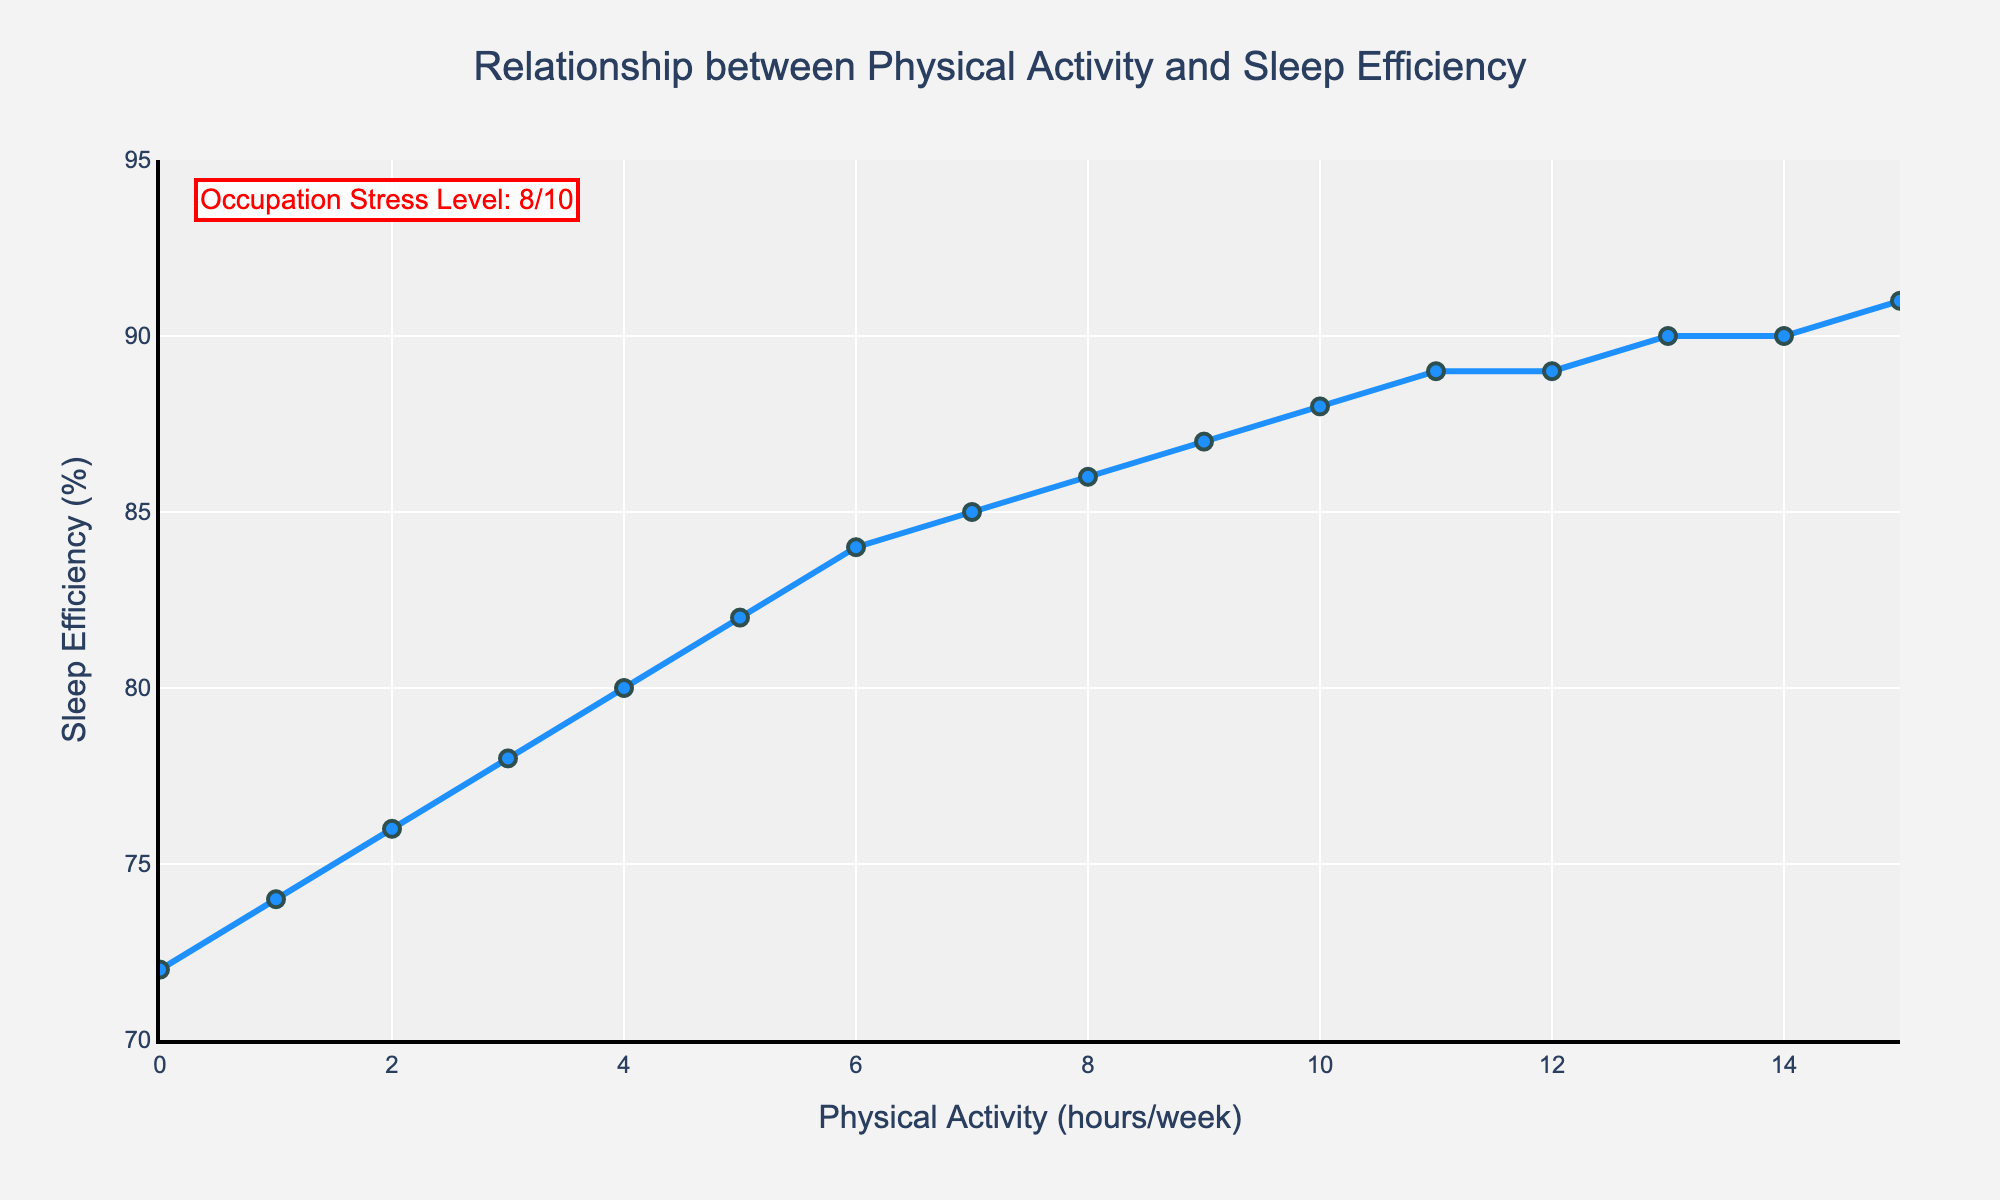What is the occupation stress level mentioned in the figure? The figure includes an annotation at the top left stating "Occupation Stress Level: 8/10".
Answer: 8/10 How does sleep efficiency change with increasing physical activity levels? The line chart shows a clear increasing trend of sleep efficiency as physical activity levels increase from 0 to 15 hours per week.
Answer: Increases What is the sleep efficiency at 10 hours of physical activity per week? From the chart, locate the point corresponding to 10 hours per week on the x-axis, then read the sleep efficiency on the y-axis, which is at 88%.
Answer: 88% At which physical activity level does sleep efficiency stop noticeably increasing? Sleep efficiency noticeably stops increasing at around 13 hours per week, with nearly equivalent values around 90%.
Answer: 13 hours per week Which physical activity level sees the highest sleep efficiency, and what is that efficiency? The highest sleep efficiency, which is 91%, occurs at the physical activity level of 15 hours per week.
Answer: 15 hours per week, 91% What is the average sleep efficiency between 0 and 5 hours of physical activity? Sum the sleep efficiencies at 0, 1, 2, 3, 4, and 5 hours per week (72 + 74 + 76 + 78 + 80 + 82) and then divide by the number of data points, which is 6. Average = (72 + 74 + 76 + 78 + 80 + 82) / 6 = 77%.
Answer: 77% Compare the sleep efficiency at 6 hours and 10 hours of physical activity per week. Which is higher and by how much? The sleep efficiency at 6 hours per week is 84%, and at 10 hours per week is 88%. The difference is 88% - 84% = 4%.
Answer: 10 hours per week, 4% What is the range of sleep efficiency values shown in the figure? The minimum sleep efficiency is 72% at 0 hours per week, and the maximum is 91% at 15 hours per week. The range is 91% - 72% = 19%.
Answer: 19% If an individual increases their physical activity from 5 to 8 hours per week, how much does their sleep efficiency improve? Sleep efficiency at 5 hours per week is 82%, and at 8 hours per week is 86%. The improvement is 86% - 82% = 4%.
Answer: 4% What is the visual color used for the line representing the relationship between physical activity levels and sleep efficiency? The line in the chart is colored in a shade of blue.
Answer: Blue 